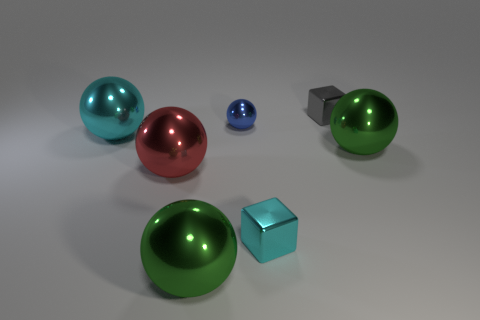Subtract all cyan balls. Subtract all purple cubes. How many balls are left? 4 Add 1 large yellow metal blocks. How many objects exist? 8 Subtract all cubes. How many objects are left? 5 Subtract all cyan metallic blocks. Subtract all tiny brown cylinders. How many objects are left? 6 Add 5 small shiny things. How many small shiny things are left? 8 Add 5 large cyan metal spheres. How many large cyan metal spheres exist? 6 Subtract 0 gray balls. How many objects are left? 7 